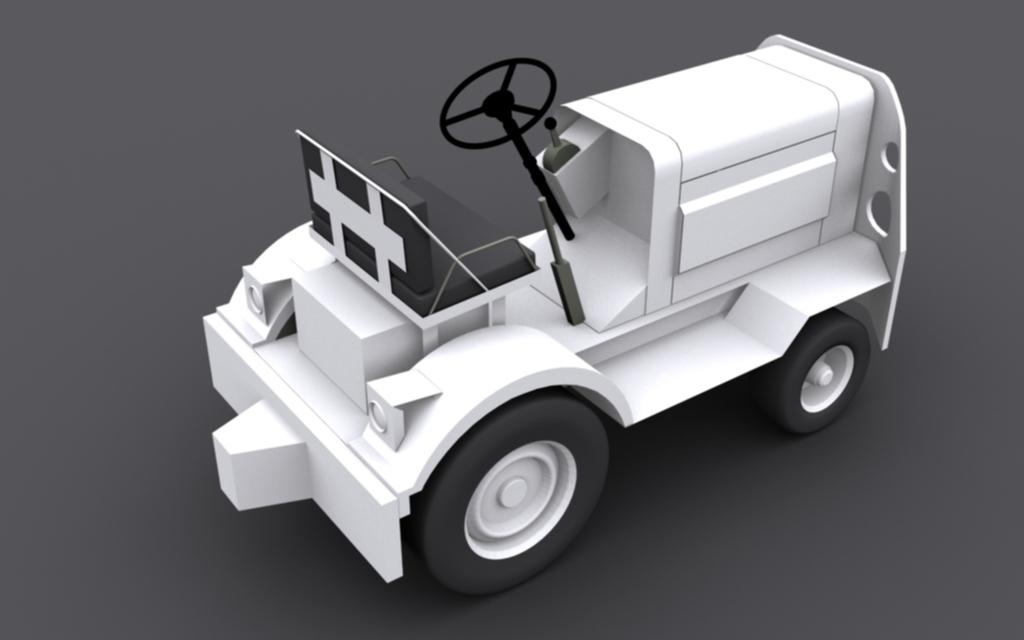What type of toy is in the image? There is a toy vehicle in the image. What feature does the toy vehicle have? The toy vehicle has a steering wheel. What part of the toy vehicle allows it to move on surfaces? The toy vehicle has tires. What type of trees can be seen in the background of the image? There are no trees visible in the image; it only features a toy vehicle. 